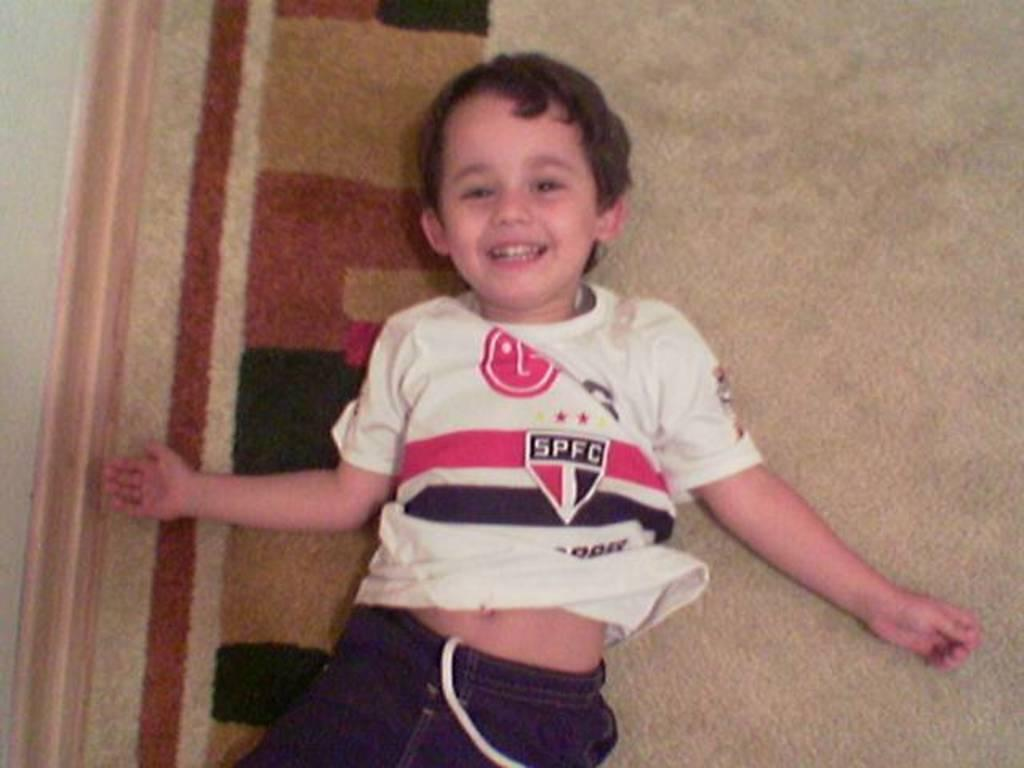<image>
Present a compact description of the photo's key features. Young boy laying on carpeting with a white shirt that has SPFC on the front. 